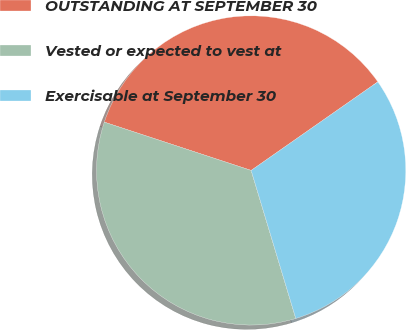<chart> <loc_0><loc_0><loc_500><loc_500><pie_chart><fcel>OUTSTANDING AT SEPTEMBER 30<fcel>Vested or expected to vest at<fcel>Exercisable at September 30<nl><fcel>35.23%<fcel>34.72%<fcel>30.05%<nl></chart> 